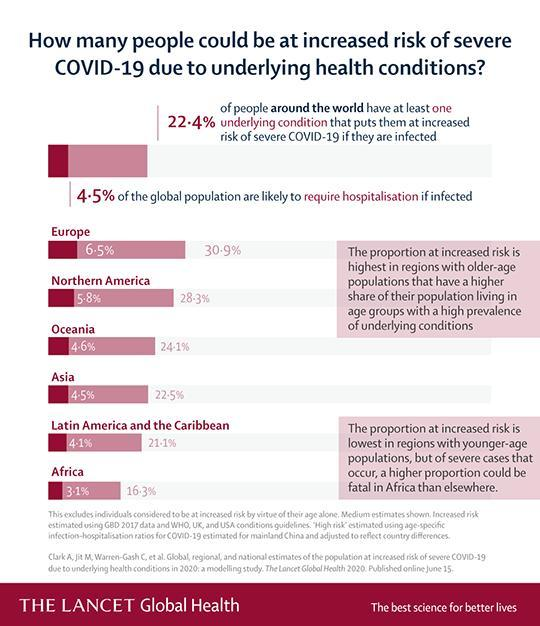If infected with covid-19, what percentage of the global population is not likely to require hospitalization?
Answer the question with a short phrase. 95.5% 